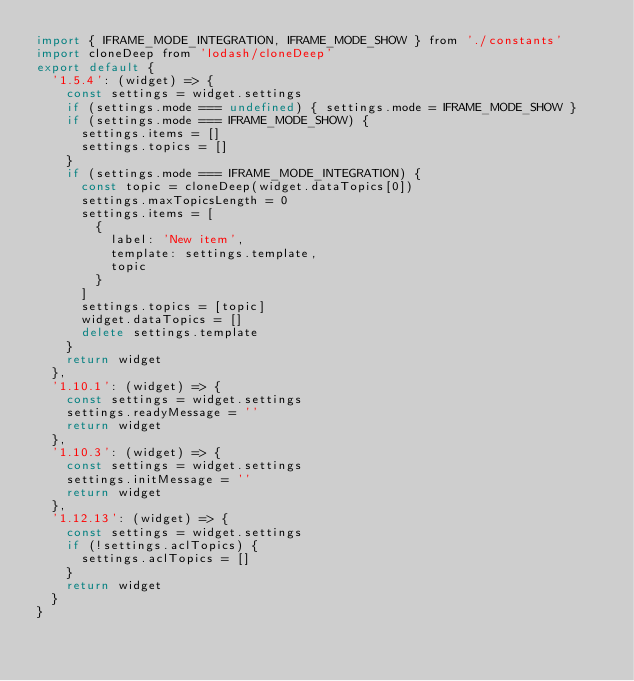Convert code to text. <code><loc_0><loc_0><loc_500><loc_500><_JavaScript_>import { IFRAME_MODE_INTEGRATION, IFRAME_MODE_SHOW } from './constants'
import cloneDeep from 'lodash/cloneDeep'
export default {
  '1.5.4': (widget) => {
    const settings = widget.settings
    if (settings.mode === undefined) { settings.mode = IFRAME_MODE_SHOW }
    if (settings.mode === IFRAME_MODE_SHOW) {
      settings.items = []
      settings.topics = []
    }
    if (settings.mode === IFRAME_MODE_INTEGRATION) {
      const topic = cloneDeep(widget.dataTopics[0])
      settings.maxTopicsLength = 0
      settings.items = [
        {
          label: 'New item',
          template: settings.template,
          topic
        }
      ]
      settings.topics = [topic]
      widget.dataTopics = []
      delete settings.template
    }
    return widget
  },
  '1.10.1': (widget) => {
    const settings = widget.settings
    settings.readyMessage = ''
    return widget
  },
  '1.10.3': (widget) => {
    const settings = widget.settings
    settings.initMessage = ''
    return widget
  },
  '1.12.13': (widget) => {
    const settings = widget.settings
    if (!settings.aclTopics) {
      settings.aclTopics = []
    }
    return widget
  }
}
</code> 